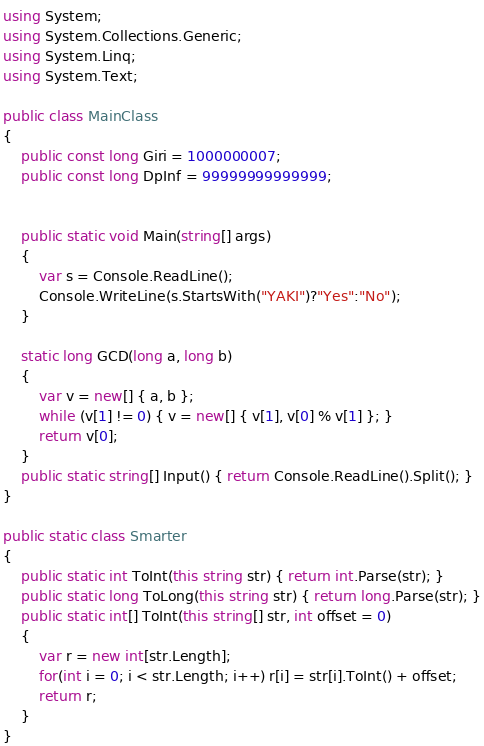Convert code to text. <code><loc_0><loc_0><loc_500><loc_500><_C#_>using System;
using System.Collections.Generic;
using System.Linq;
using System.Text;

public class MainClass
{
	public const long Giri = 1000000007;
	public const long DpInf = 99999999999999;

	
	public static void Main(string[] args)
	{
		var s = Console.ReadLine();
		Console.WriteLine(s.StartsWith("YAKI")?"Yes":"No");
	}
	
	static long GCD(long a, long b)
	{
		var v = new[] { a, b };
		while (v[1] != 0) { v = new[] { v[1], v[0] % v[1] }; }
		return v[0];
	}
	public static string[] Input() { return Console.ReadLine().Split(); }
}

public static class Smarter
{
	public static int ToInt(this string str) { return int.Parse(str); }
	public static long ToLong(this string str) { return long.Parse(str); }
	public static int[] ToInt(this string[] str, int offset = 0)
	{
		var r = new int[str.Length];
		for(int i = 0; i < str.Length; i++) r[i] = str[i].ToInt() + offset;
		return r;
	}
}</code> 